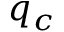<formula> <loc_0><loc_0><loc_500><loc_500>q _ { c }</formula> 